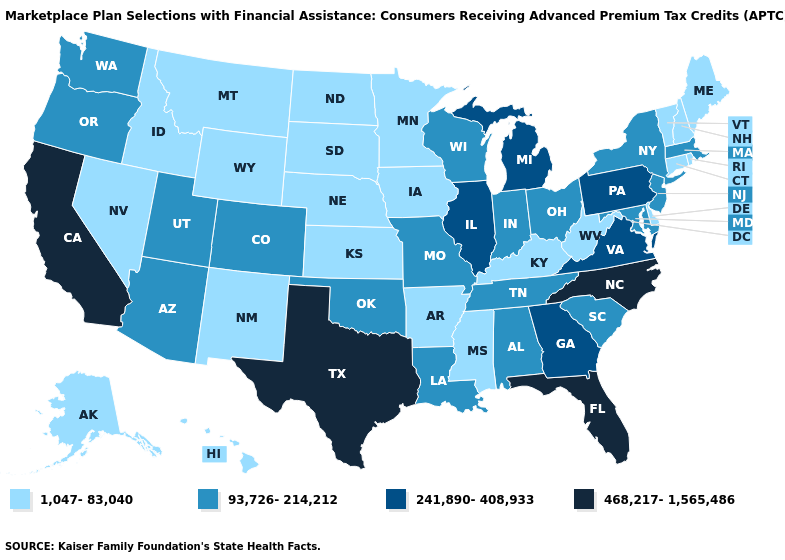Name the states that have a value in the range 241,890-408,933?
Answer briefly. Georgia, Illinois, Michigan, Pennsylvania, Virginia. Name the states that have a value in the range 468,217-1,565,486?
Be succinct. California, Florida, North Carolina, Texas. Does South Carolina have the highest value in the USA?
Keep it brief. No. What is the highest value in states that border Oregon?
Write a very short answer. 468,217-1,565,486. What is the value of Alaska?
Write a very short answer. 1,047-83,040. Does California have the highest value in the West?
Keep it brief. Yes. Name the states that have a value in the range 241,890-408,933?
Concise answer only. Georgia, Illinois, Michigan, Pennsylvania, Virginia. Does Maryland have a lower value than Florida?
Write a very short answer. Yes. What is the highest value in the USA?
Give a very brief answer. 468,217-1,565,486. Does Ohio have the same value as Arizona?
Write a very short answer. Yes. Does California have the highest value in the West?
Give a very brief answer. Yes. Does Pennsylvania have the highest value in the Northeast?
Keep it brief. Yes. Does the first symbol in the legend represent the smallest category?
Be succinct. Yes. Does Pennsylvania have the highest value in the Northeast?
Give a very brief answer. Yes. Is the legend a continuous bar?
Concise answer only. No. 